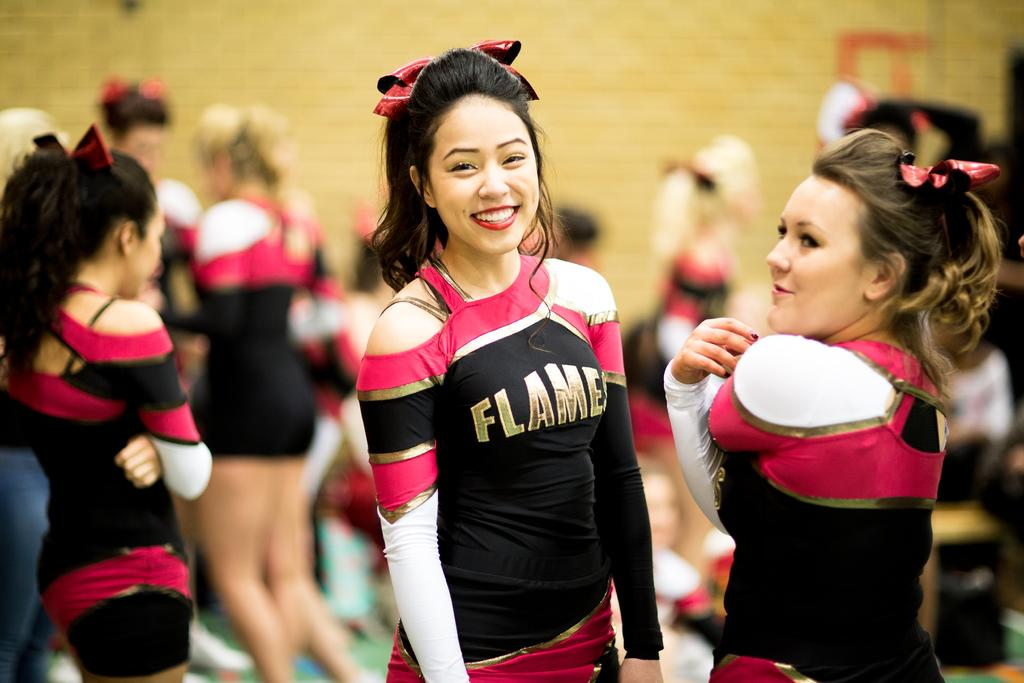<image>
Write a terse but informative summary of the picture. A girl smiles for the camera in her cheer uniform that says FLAMES 